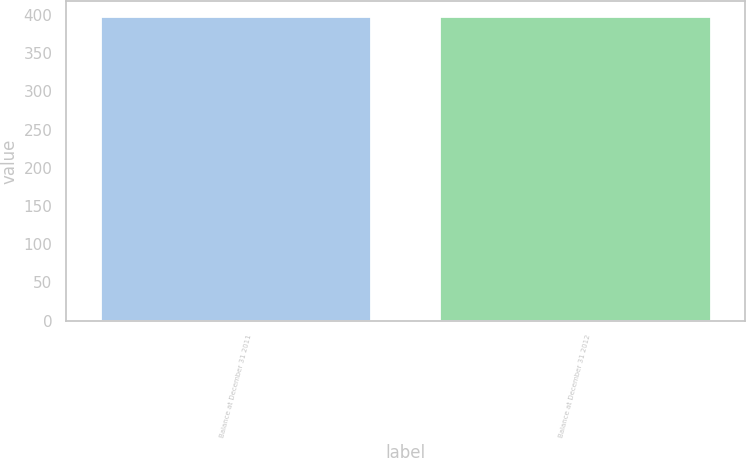Convert chart to OTSL. <chart><loc_0><loc_0><loc_500><loc_500><bar_chart><fcel>Balance at December 31 2011<fcel>Balance at December 31 2012<nl><fcel>398<fcel>398.1<nl></chart> 